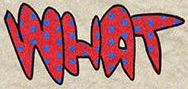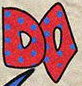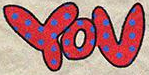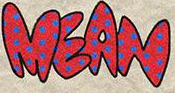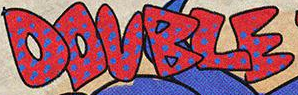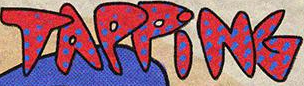What words are shown in these images in order, separated by a semicolon? WHAT; DO; YOU; MEAN; DOUBLE; TAPPiNG 